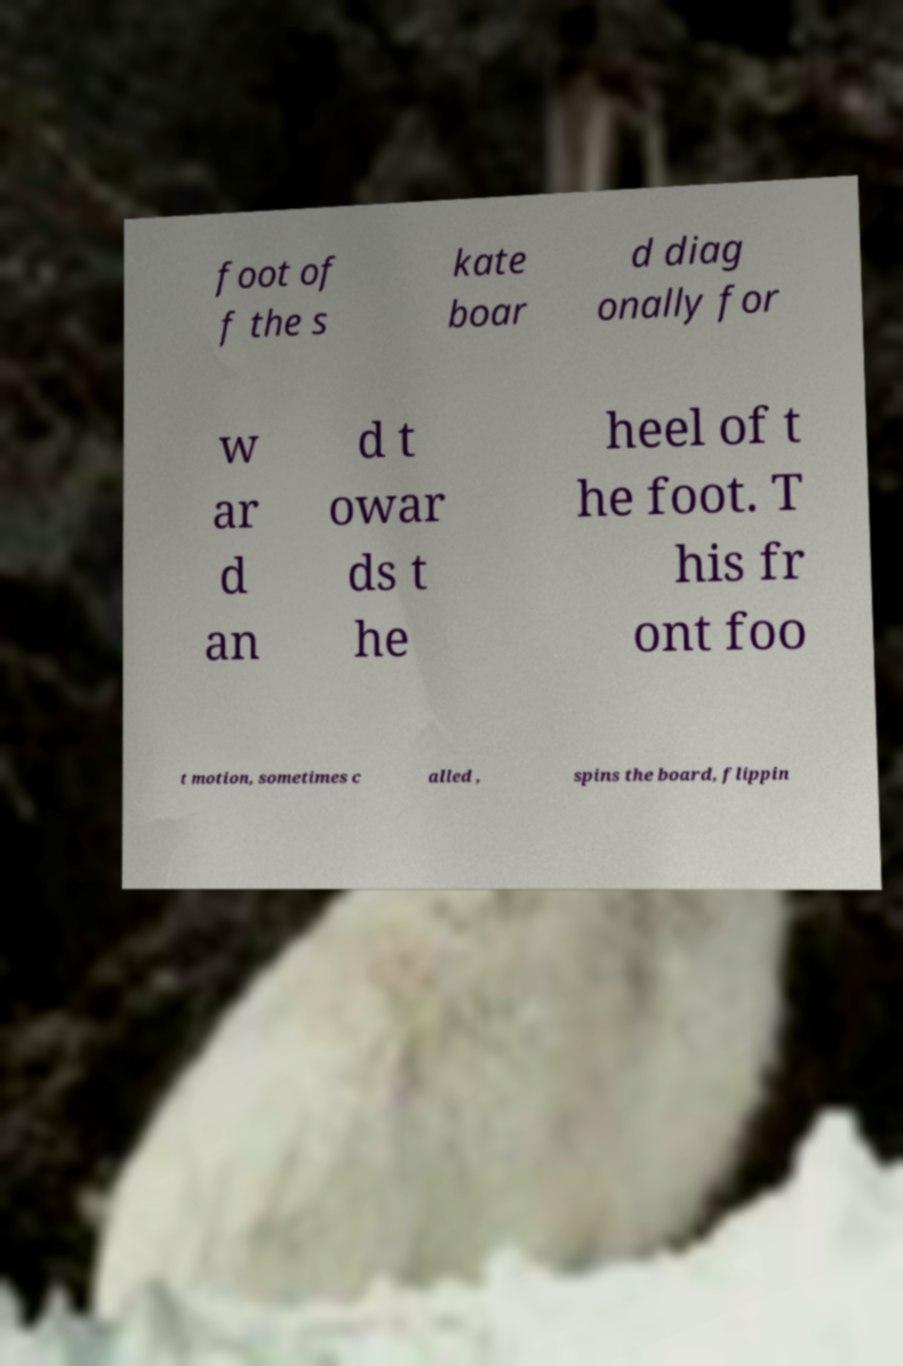For documentation purposes, I need the text within this image transcribed. Could you provide that? foot of f the s kate boar d diag onally for w ar d an d t owar ds t he heel of t he foot. T his fr ont foo t motion, sometimes c alled , spins the board, flippin 